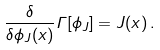<formula> <loc_0><loc_0><loc_500><loc_500>\frac { \delta } { \delta \phi _ { J } ( x ) } \Gamma [ \phi _ { J } ] = J ( x ) \, .</formula> 